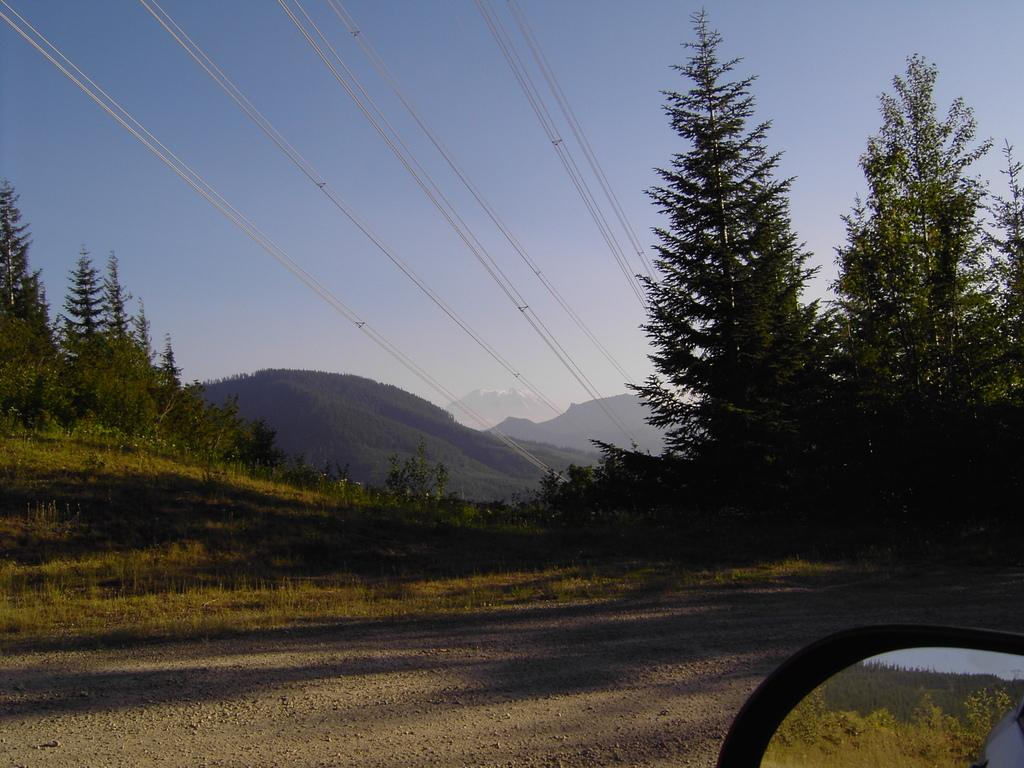What type of vegetation can be seen in the image? There are trees in the image. What object is located at the bottom of the image? There is a car mirror at the bottom of the image. What can be seen in the background of the image? There are hills, wires, and the sky visible in the background of the image. Can you tell me how many eyes are visible on the floor in the image? There are no eyes visible on the floor in the image. What type of porter is carrying the hills in the background of the image? There is no porter present in the image, and the hills are not being carried by anyone. 